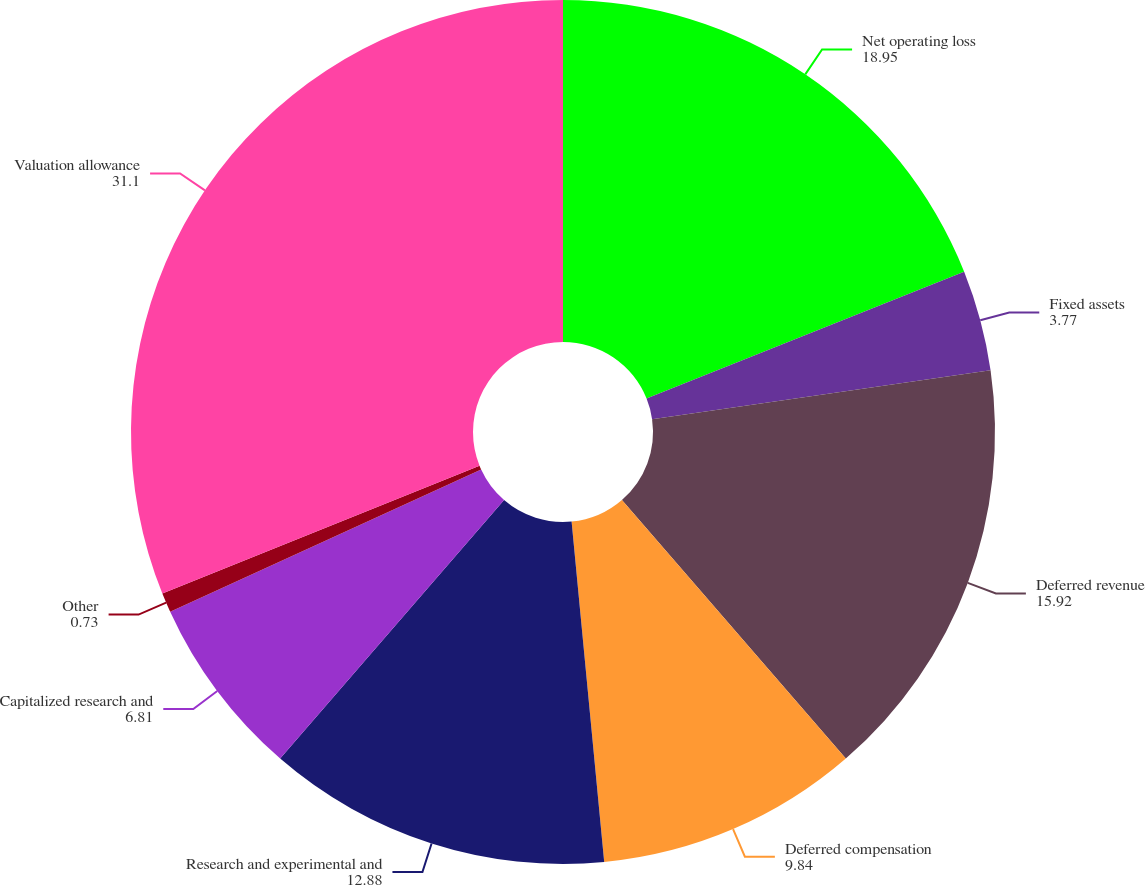Convert chart to OTSL. <chart><loc_0><loc_0><loc_500><loc_500><pie_chart><fcel>Net operating loss<fcel>Fixed assets<fcel>Deferred revenue<fcel>Deferred compensation<fcel>Research and experimental and<fcel>Capitalized research and<fcel>Other<fcel>Valuation allowance<nl><fcel>18.95%<fcel>3.77%<fcel>15.92%<fcel>9.84%<fcel>12.88%<fcel>6.81%<fcel>0.73%<fcel>31.1%<nl></chart> 